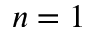<formula> <loc_0><loc_0><loc_500><loc_500>n = 1</formula> 